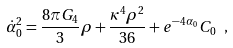<formula> <loc_0><loc_0><loc_500><loc_500>\dot { \alpha } _ { 0 } ^ { 2 } = \frac { 8 \pi G _ { 4 } } { 3 } \rho + \frac { \kappa ^ { 4 } \rho ^ { 2 } } { 3 6 } + e ^ { - 4 \alpha _ { 0 } } C _ { 0 } \ ,</formula> 